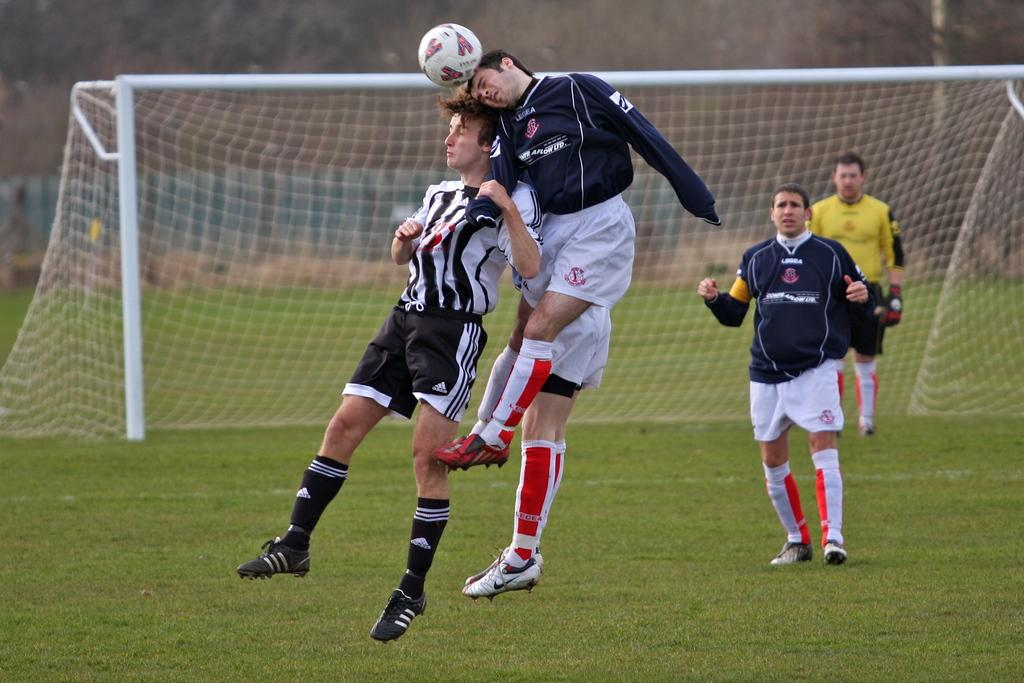How many people are in the image? There is a group of people in the image. What are three people doing in the image? Three people are jumping in the image. What are two people doing in the image? Two people are standing on the grass in the image. What object is present in the image that is commonly used in sports? There is a ball in the image. What structure is present in the image that is used in sports like volleyball or tennis? There is a net in the image. What type of natural scenery can be seen in the background of the image? There are trees in the background of the image. What architectural feature can be seen in the background of the image? There is a fence in the background of the image. How would you describe the appearance of the background in the image? The background appears blurry. What type of bread is being used to play the songs in the image? There is no bread or songs present in the image. 